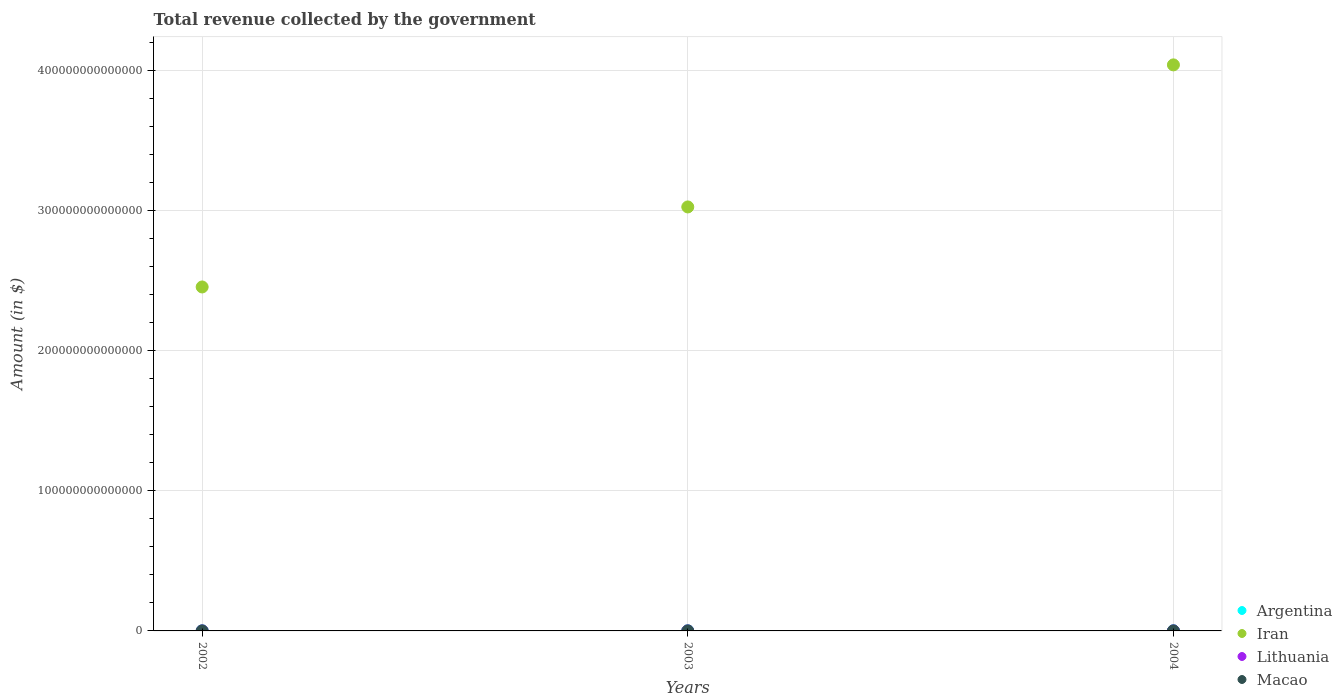How many different coloured dotlines are there?
Provide a succinct answer. 4. What is the total revenue collected by the government in Argentina in 2002?
Offer a very short reply. 4.39e+1. Across all years, what is the maximum total revenue collected by the government in Iran?
Offer a very short reply. 4.04e+14. Across all years, what is the minimum total revenue collected by the government in Lithuania?
Give a very brief answer. 1.46e+1. In which year was the total revenue collected by the government in Macao maximum?
Keep it short and to the point. 2004. In which year was the total revenue collected by the government in Lithuania minimum?
Ensure brevity in your answer.  2002. What is the total total revenue collected by the government in Argentina in the graph?
Provide a succinct answer. 1.90e+11. What is the difference between the total revenue collected by the government in Iran in 2003 and that in 2004?
Your answer should be very brief. -1.01e+14. What is the difference between the total revenue collected by the government in Argentina in 2004 and the total revenue collected by the government in Iran in 2003?
Your answer should be compact. -3.03e+14. What is the average total revenue collected by the government in Macao per year?
Keep it short and to the point. 1.58e+1. In the year 2002, what is the difference between the total revenue collected by the government in Iran and total revenue collected by the government in Argentina?
Your response must be concise. 2.46e+14. What is the ratio of the total revenue collected by the government in Argentina in 2002 to that in 2003?
Provide a succinct answer. 0.68. What is the difference between the highest and the second highest total revenue collected by the government in Macao?
Keep it short and to the point. 4.96e+09. What is the difference between the highest and the lowest total revenue collected by the government in Lithuania?
Make the answer very short. 2.85e+09. Does the total revenue collected by the government in Argentina monotonically increase over the years?
Provide a short and direct response. Yes. How many dotlines are there?
Offer a very short reply. 4. What is the difference between two consecutive major ticks on the Y-axis?
Provide a succinct answer. 1.00e+14. Are the values on the major ticks of Y-axis written in scientific E-notation?
Offer a terse response. No. Where does the legend appear in the graph?
Your answer should be compact. Bottom right. How are the legend labels stacked?
Your answer should be very brief. Vertical. What is the title of the graph?
Offer a terse response. Total revenue collected by the government. Does "Jordan" appear as one of the legend labels in the graph?
Your answer should be compact. No. What is the label or title of the Y-axis?
Make the answer very short. Amount (in $). What is the Amount (in $) in Argentina in 2002?
Give a very brief answer. 4.39e+1. What is the Amount (in $) of Iran in 2002?
Your answer should be compact. 2.46e+14. What is the Amount (in $) in Lithuania in 2002?
Your answer should be compact. 1.46e+1. What is the Amount (in $) of Macao in 2002?
Provide a succinct answer. 1.19e+1. What is the Amount (in $) of Argentina in 2003?
Keep it short and to the point. 6.47e+1. What is the Amount (in $) of Iran in 2003?
Give a very brief answer. 3.03e+14. What is the Amount (in $) in Lithuania in 2003?
Provide a short and direct response. 1.57e+1. What is the Amount (in $) of Macao in 2003?
Offer a very short reply. 1.53e+1. What is the Amount (in $) of Argentina in 2004?
Your response must be concise. 8.12e+1. What is the Amount (in $) in Iran in 2004?
Offer a terse response. 4.04e+14. What is the Amount (in $) in Lithuania in 2004?
Offer a very short reply. 1.74e+1. What is the Amount (in $) in Macao in 2004?
Provide a short and direct response. 2.02e+1. Across all years, what is the maximum Amount (in $) in Argentina?
Keep it short and to the point. 8.12e+1. Across all years, what is the maximum Amount (in $) of Iran?
Keep it short and to the point. 4.04e+14. Across all years, what is the maximum Amount (in $) in Lithuania?
Ensure brevity in your answer.  1.74e+1. Across all years, what is the maximum Amount (in $) of Macao?
Your answer should be compact. 2.02e+1. Across all years, what is the minimum Amount (in $) of Argentina?
Your answer should be very brief. 4.39e+1. Across all years, what is the minimum Amount (in $) of Iran?
Make the answer very short. 2.46e+14. Across all years, what is the minimum Amount (in $) of Lithuania?
Provide a short and direct response. 1.46e+1. Across all years, what is the minimum Amount (in $) in Macao?
Make the answer very short. 1.19e+1. What is the total Amount (in $) in Argentina in the graph?
Give a very brief answer. 1.90e+11. What is the total Amount (in $) of Iran in the graph?
Your answer should be very brief. 9.53e+14. What is the total Amount (in $) in Lithuania in the graph?
Provide a succinct answer. 4.76e+1. What is the total Amount (in $) in Macao in the graph?
Provide a short and direct response. 4.74e+1. What is the difference between the Amount (in $) in Argentina in 2002 and that in 2003?
Ensure brevity in your answer.  -2.07e+1. What is the difference between the Amount (in $) of Iran in 2002 and that in 2003?
Offer a very short reply. -5.71e+13. What is the difference between the Amount (in $) of Lithuania in 2002 and that in 2003?
Offer a very short reply. -1.13e+09. What is the difference between the Amount (in $) of Macao in 2002 and that in 2003?
Your response must be concise. -3.39e+09. What is the difference between the Amount (in $) of Argentina in 2002 and that in 2004?
Ensure brevity in your answer.  -3.72e+1. What is the difference between the Amount (in $) of Iran in 2002 and that in 2004?
Offer a very short reply. -1.59e+14. What is the difference between the Amount (in $) in Lithuania in 2002 and that in 2004?
Keep it short and to the point. -2.85e+09. What is the difference between the Amount (in $) in Macao in 2002 and that in 2004?
Give a very brief answer. -8.35e+09. What is the difference between the Amount (in $) in Argentina in 2003 and that in 2004?
Make the answer very short. -1.65e+1. What is the difference between the Amount (in $) in Iran in 2003 and that in 2004?
Offer a very short reply. -1.01e+14. What is the difference between the Amount (in $) of Lithuania in 2003 and that in 2004?
Your answer should be very brief. -1.72e+09. What is the difference between the Amount (in $) in Macao in 2003 and that in 2004?
Provide a short and direct response. -4.96e+09. What is the difference between the Amount (in $) of Argentina in 2002 and the Amount (in $) of Iran in 2003?
Your answer should be very brief. -3.03e+14. What is the difference between the Amount (in $) in Argentina in 2002 and the Amount (in $) in Lithuania in 2003?
Make the answer very short. 2.83e+1. What is the difference between the Amount (in $) in Argentina in 2002 and the Amount (in $) in Macao in 2003?
Your answer should be very brief. 2.86e+1. What is the difference between the Amount (in $) in Iran in 2002 and the Amount (in $) in Lithuania in 2003?
Offer a terse response. 2.46e+14. What is the difference between the Amount (in $) in Iran in 2002 and the Amount (in $) in Macao in 2003?
Provide a short and direct response. 2.46e+14. What is the difference between the Amount (in $) in Lithuania in 2002 and the Amount (in $) in Macao in 2003?
Provide a short and direct response. -7.39e+08. What is the difference between the Amount (in $) of Argentina in 2002 and the Amount (in $) of Iran in 2004?
Ensure brevity in your answer.  -4.04e+14. What is the difference between the Amount (in $) in Argentina in 2002 and the Amount (in $) in Lithuania in 2004?
Ensure brevity in your answer.  2.65e+1. What is the difference between the Amount (in $) in Argentina in 2002 and the Amount (in $) in Macao in 2004?
Offer a very short reply. 2.37e+1. What is the difference between the Amount (in $) of Iran in 2002 and the Amount (in $) of Lithuania in 2004?
Offer a very short reply. 2.46e+14. What is the difference between the Amount (in $) of Iran in 2002 and the Amount (in $) of Macao in 2004?
Provide a succinct answer. 2.46e+14. What is the difference between the Amount (in $) in Lithuania in 2002 and the Amount (in $) in Macao in 2004?
Your answer should be compact. -5.70e+09. What is the difference between the Amount (in $) of Argentina in 2003 and the Amount (in $) of Iran in 2004?
Offer a terse response. -4.04e+14. What is the difference between the Amount (in $) in Argentina in 2003 and the Amount (in $) in Lithuania in 2004?
Provide a succinct answer. 4.73e+1. What is the difference between the Amount (in $) of Argentina in 2003 and the Amount (in $) of Macao in 2004?
Ensure brevity in your answer.  4.44e+1. What is the difference between the Amount (in $) in Iran in 2003 and the Amount (in $) in Lithuania in 2004?
Give a very brief answer. 3.03e+14. What is the difference between the Amount (in $) in Iran in 2003 and the Amount (in $) in Macao in 2004?
Ensure brevity in your answer.  3.03e+14. What is the difference between the Amount (in $) of Lithuania in 2003 and the Amount (in $) of Macao in 2004?
Offer a terse response. -4.57e+09. What is the average Amount (in $) of Argentina per year?
Keep it short and to the point. 6.33e+1. What is the average Amount (in $) in Iran per year?
Your answer should be very brief. 3.18e+14. What is the average Amount (in $) of Lithuania per year?
Your answer should be very brief. 1.59e+1. What is the average Amount (in $) of Macao per year?
Ensure brevity in your answer.  1.58e+1. In the year 2002, what is the difference between the Amount (in $) in Argentina and Amount (in $) in Iran?
Provide a succinct answer. -2.46e+14. In the year 2002, what is the difference between the Amount (in $) of Argentina and Amount (in $) of Lithuania?
Provide a succinct answer. 2.94e+1. In the year 2002, what is the difference between the Amount (in $) of Argentina and Amount (in $) of Macao?
Your response must be concise. 3.20e+1. In the year 2002, what is the difference between the Amount (in $) in Iran and Amount (in $) in Lithuania?
Keep it short and to the point. 2.46e+14. In the year 2002, what is the difference between the Amount (in $) in Iran and Amount (in $) in Macao?
Keep it short and to the point. 2.46e+14. In the year 2002, what is the difference between the Amount (in $) of Lithuania and Amount (in $) of Macao?
Give a very brief answer. 2.66e+09. In the year 2003, what is the difference between the Amount (in $) of Argentina and Amount (in $) of Iran?
Provide a short and direct response. -3.03e+14. In the year 2003, what is the difference between the Amount (in $) of Argentina and Amount (in $) of Lithuania?
Your response must be concise. 4.90e+1. In the year 2003, what is the difference between the Amount (in $) of Argentina and Amount (in $) of Macao?
Offer a very short reply. 4.94e+1. In the year 2003, what is the difference between the Amount (in $) of Iran and Amount (in $) of Lithuania?
Provide a short and direct response. 3.03e+14. In the year 2003, what is the difference between the Amount (in $) in Iran and Amount (in $) in Macao?
Make the answer very short. 3.03e+14. In the year 2003, what is the difference between the Amount (in $) in Lithuania and Amount (in $) in Macao?
Give a very brief answer. 3.91e+08. In the year 2004, what is the difference between the Amount (in $) of Argentina and Amount (in $) of Iran?
Make the answer very short. -4.04e+14. In the year 2004, what is the difference between the Amount (in $) of Argentina and Amount (in $) of Lithuania?
Your answer should be very brief. 6.38e+1. In the year 2004, what is the difference between the Amount (in $) in Argentina and Amount (in $) in Macao?
Ensure brevity in your answer.  6.09e+1. In the year 2004, what is the difference between the Amount (in $) in Iran and Amount (in $) in Lithuania?
Your response must be concise. 4.04e+14. In the year 2004, what is the difference between the Amount (in $) of Iran and Amount (in $) of Macao?
Provide a short and direct response. 4.04e+14. In the year 2004, what is the difference between the Amount (in $) in Lithuania and Amount (in $) in Macao?
Offer a terse response. -2.85e+09. What is the ratio of the Amount (in $) of Argentina in 2002 to that in 2003?
Offer a very short reply. 0.68. What is the ratio of the Amount (in $) in Iran in 2002 to that in 2003?
Provide a succinct answer. 0.81. What is the ratio of the Amount (in $) of Lithuania in 2002 to that in 2003?
Provide a succinct answer. 0.93. What is the ratio of the Amount (in $) in Macao in 2002 to that in 2003?
Your answer should be compact. 0.78. What is the ratio of the Amount (in $) of Argentina in 2002 to that in 2004?
Keep it short and to the point. 0.54. What is the ratio of the Amount (in $) of Iran in 2002 to that in 2004?
Keep it short and to the point. 0.61. What is the ratio of the Amount (in $) in Lithuania in 2002 to that in 2004?
Provide a succinct answer. 0.84. What is the ratio of the Amount (in $) in Macao in 2002 to that in 2004?
Ensure brevity in your answer.  0.59. What is the ratio of the Amount (in $) of Argentina in 2003 to that in 2004?
Provide a succinct answer. 0.8. What is the ratio of the Amount (in $) of Iran in 2003 to that in 2004?
Your answer should be compact. 0.75. What is the ratio of the Amount (in $) in Lithuania in 2003 to that in 2004?
Offer a terse response. 0.9. What is the ratio of the Amount (in $) of Macao in 2003 to that in 2004?
Give a very brief answer. 0.76. What is the difference between the highest and the second highest Amount (in $) in Argentina?
Provide a short and direct response. 1.65e+1. What is the difference between the highest and the second highest Amount (in $) of Iran?
Make the answer very short. 1.01e+14. What is the difference between the highest and the second highest Amount (in $) of Lithuania?
Keep it short and to the point. 1.72e+09. What is the difference between the highest and the second highest Amount (in $) in Macao?
Give a very brief answer. 4.96e+09. What is the difference between the highest and the lowest Amount (in $) of Argentina?
Give a very brief answer. 3.72e+1. What is the difference between the highest and the lowest Amount (in $) of Iran?
Provide a succinct answer. 1.59e+14. What is the difference between the highest and the lowest Amount (in $) in Lithuania?
Your answer should be compact. 2.85e+09. What is the difference between the highest and the lowest Amount (in $) of Macao?
Offer a very short reply. 8.35e+09. 